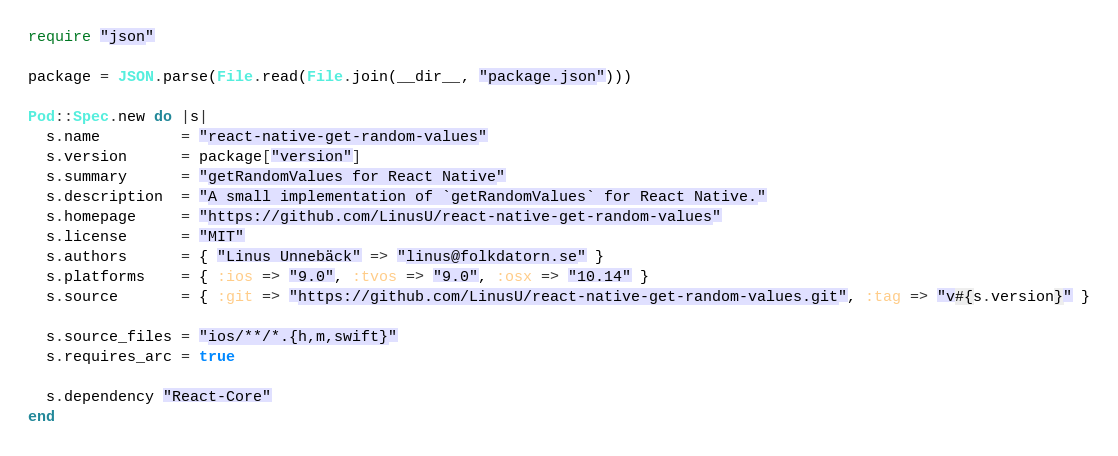Convert code to text. <code><loc_0><loc_0><loc_500><loc_500><_Ruby_>require "json"

package = JSON.parse(File.read(File.join(__dir__, "package.json")))

Pod::Spec.new do |s|
  s.name         = "react-native-get-random-values"
  s.version      = package["version"]
  s.summary      = "getRandomValues for React Native"
  s.description  = "A small implementation of `getRandomValues` for React Native."
  s.homepage     = "https://github.com/LinusU/react-native-get-random-values"
  s.license      = "MIT"
  s.authors      = { "Linus Unnebäck" => "linus@folkdatorn.se" }
  s.platforms    = { :ios => "9.0", :tvos => "9.0", :osx => "10.14" }
  s.source       = { :git => "https://github.com/LinusU/react-native-get-random-values.git", :tag => "v#{s.version}" }

  s.source_files = "ios/**/*.{h,m,swift}"
  s.requires_arc = true

  s.dependency "React-Core"
end
</code> 